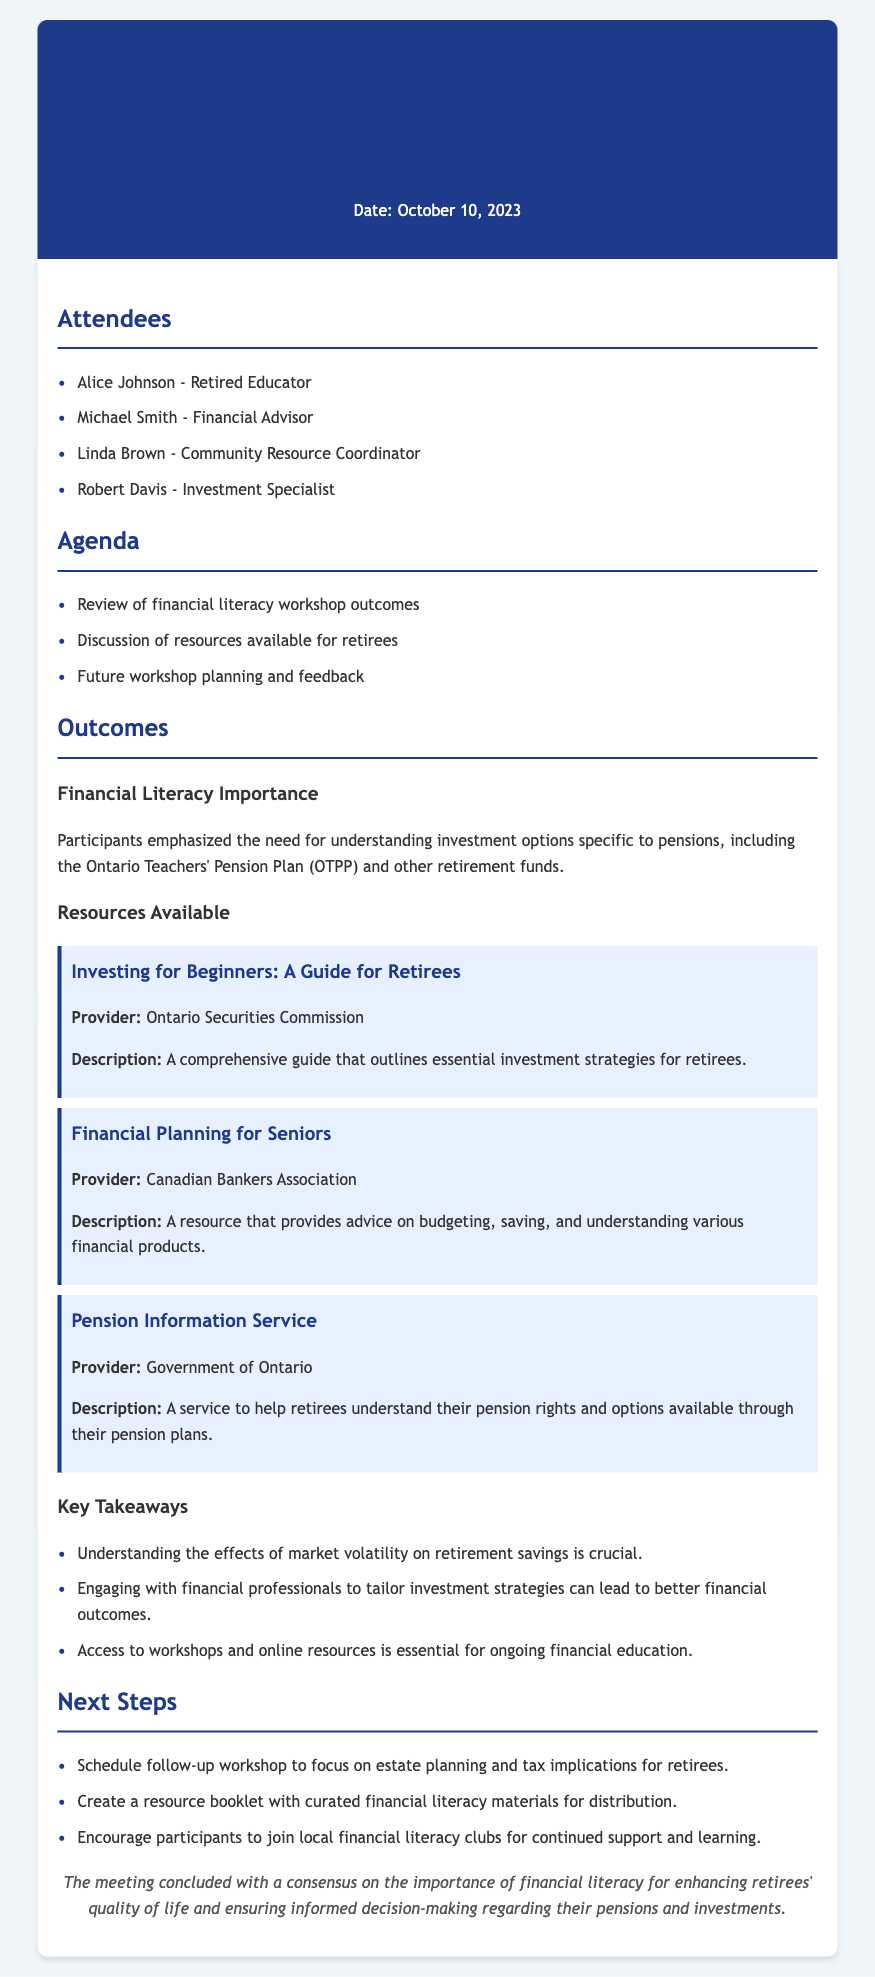What was the date of the workshop? The date is mentioned at the top of the document under the header.
Answer: October 10, 2023 Who is the provider of the resource "Investing for Beginners: A Guide for Retirees"? The document lists the provider under the resource description.
Answer: Ontario Securities Commission What is one of the key takeaways mentioned in the document? Key takeaways are summarized in a list, highlighting important points from the discussion.
Answer: Understanding the effects of market volatility on retirement savings is crucial What is the purpose of the "Pension Information Service"? The description of this service is provided in the section about resources available for retirees.
Answer: To help retirees understand their pension rights and options available through their pension plans Which financial organization is involved in providing "Financial Planning for Seniors"? The provider is noted next to this resource in the document.
Answer: Canadian Bankers Association How many attendees were listed in the meeting? The attendees are listed in a bullet format at the beginning of the content section.
Answer: Four What is suggested as a next step in the document? The next steps are outlined towards the end of the document, indicating future actions to be taken.
Answer: Schedule follow-up workshop to focus on estate planning and tax implications for retirees What was emphasized regarding the importance of financial literacy? The outcomes section discusses the importance of financial literacy specifically related to pensions.
Answer: Understanding investment options specific to pensions is crucial 